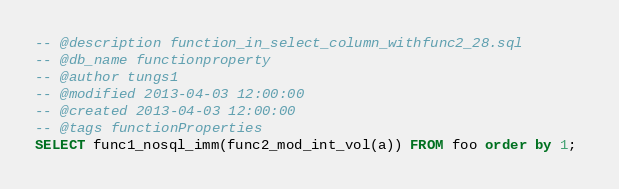<code> <loc_0><loc_0><loc_500><loc_500><_SQL_>-- @description function_in_select_column_withfunc2_28.sql
-- @db_name functionproperty
-- @author tungs1
-- @modified 2013-04-03 12:00:00
-- @created 2013-04-03 12:00:00
-- @tags functionProperties 
SELECT func1_nosql_imm(func2_mod_int_vol(a)) FROM foo order by 1; 
</code> 